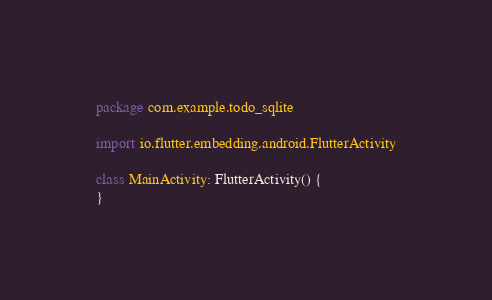<code> <loc_0><loc_0><loc_500><loc_500><_Kotlin_>package com.example.todo_sqlite

import io.flutter.embedding.android.FlutterActivity

class MainActivity: FlutterActivity() {
}
</code> 